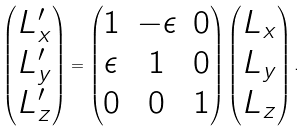<formula> <loc_0><loc_0><loc_500><loc_500>\begin{pmatrix} L _ { x } ^ { \prime } \\ L _ { y } ^ { \prime } \\ L _ { z } ^ { \prime } \end{pmatrix} = \begin{pmatrix} 1 & - \epsilon & 0 \\ \epsilon & 1 & 0 \\ 0 & 0 & 1 \end{pmatrix} \begin{pmatrix} L _ { x } \\ L _ { y } \\ L _ { z } \end{pmatrix} .</formula> 